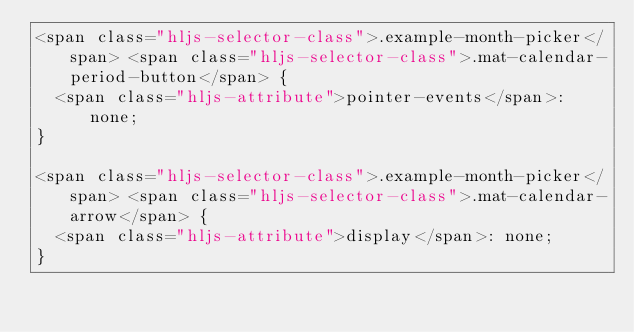<code> <loc_0><loc_0><loc_500><loc_500><_HTML_><span class="hljs-selector-class">.example-month-picker</span> <span class="hljs-selector-class">.mat-calendar-period-button</span> {
  <span class="hljs-attribute">pointer-events</span>: none;
}

<span class="hljs-selector-class">.example-month-picker</span> <span class="hljs-selector-class">.mat-calendar-arrow</span> {
  <span class="hljs-attribute">display</span>: none;
}
</code> 